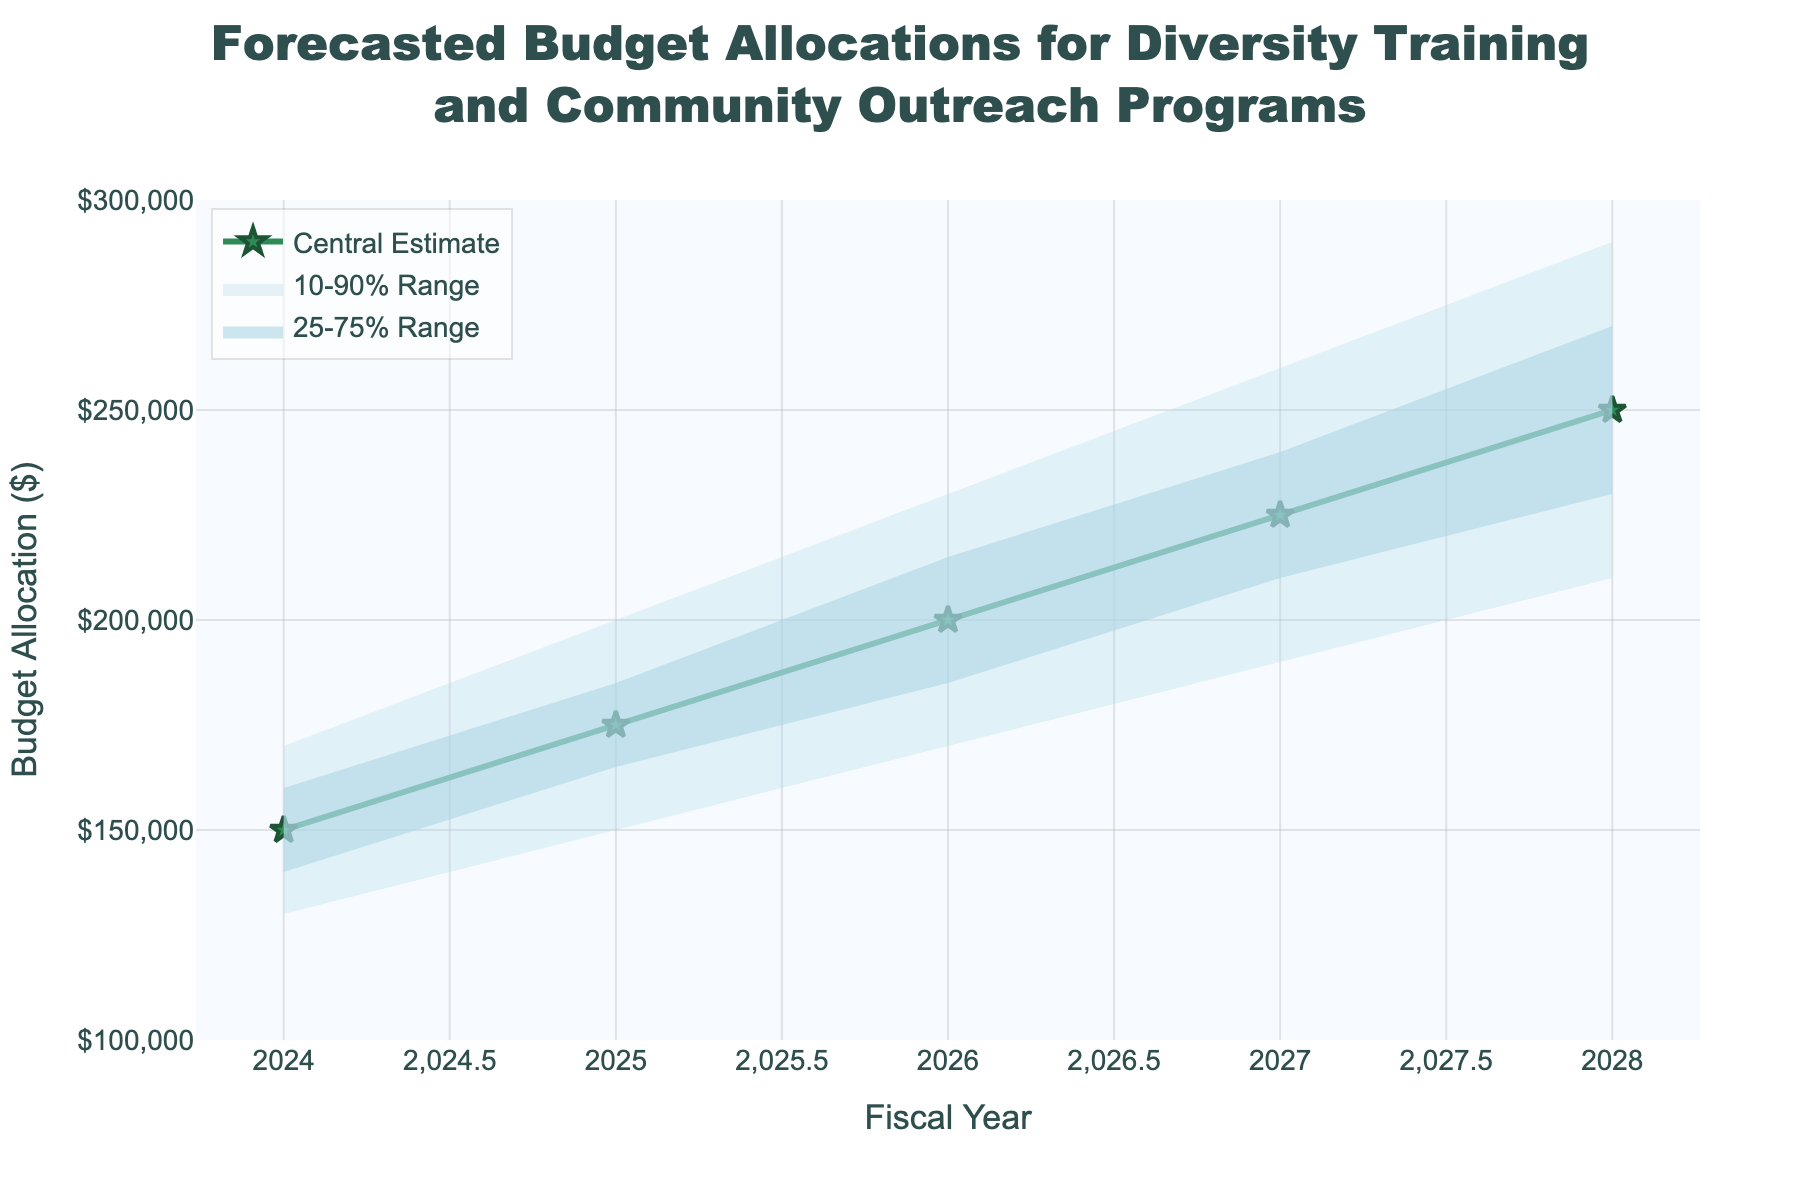What's the title of the figure? The title of a figure is usually located at the top center. In this case, it reads "Forecasted Budget Allocations for Diversity Training and Community Outreach Programs".
Answer: Forecasted Budget Allocations for Diversity Training and Community Outreach Programs What is the projected central budget estimate for the year 2026? The budget estimates for each year are shown as stars connected by a line. For the year 2026, the budget estimate corresponds to $200,000, as indicated by the marking star and the y-axis.
Answer: $200,000 What is the range of the budget allocations covered by the 10-90% interval for the year 2025? The 10-90% interval represents the spread of values between the lower 10% and upper 90% predictions. For 2025, the lower 10% is $150,000 and the upper 90% is $200,000.
Answer: $150,000 to $200,000 By how much is the 2028 central budget estimate higher than the 2024 central budget estimate? Subtract the 2024 central estimate ($150,000) from the 2028 central estimate ($250,000): $250,000 - $150,000.
Answer: $100,000 Compared to 2027, what is the increase in the lower 25% of the budget forecast for 2028? The lower 25% forecast for 2028 is $230,000, and for 2027 it is $210,000. The difference is $230,000 - $210,000.
Answer: $20,000 In which year is the upper 75% forecast budget the highest and what is it? The upper 75% budget increases each year, with the highest value in 2028 at $270,000, as indicated by the line filling the 75% boundary.
Answer: 2028, $270,000 What is the average central budget estimate over the 5 fiscal years? Sum the central estimates for each year ($150,000 + $175,000 + $200,000 + $225,000 + $250,000) and divide by the number of years (5): (150000 + 175000 + 200000 + 225000 + 250000) / 5.
Answer: $200,000 Which year shows the smallest spread between the upper 90% and lower 10% forecasts? Calculate the spreads for each year by subtracting the lower 10% forecast from the upper 90% forecast: 2024: 170000-130000=$40,000, 2025: 200000-150000=$50,000, 2026: 230000-170000=$60,000, 2027: 260000-190000=$70,000, 2028: 290000-210000=$80,000. The smallest spread is in 2024.
Answer: 2024 What is the difference in the central estimate budget between 2025 and 2026? Subtract the 2025 central estimate ($175,000) from the 2026 central estimate ($200,000): $200,000 - $175,000.
Answer: $25,000 How does the structure of the fan chart illustrate uncertainty in future budget allocations? The fan chart uses shaded areas to show different confidence intervals (10-90% and 25-75%). Wider spans represent higher uncertainty, and narrower spans represent lower uncertainty. As time progresses, the shaded areas widen, indicating increasing uncertainty.
Answer: Widening shaded areas represent increasing uncertainty over time 